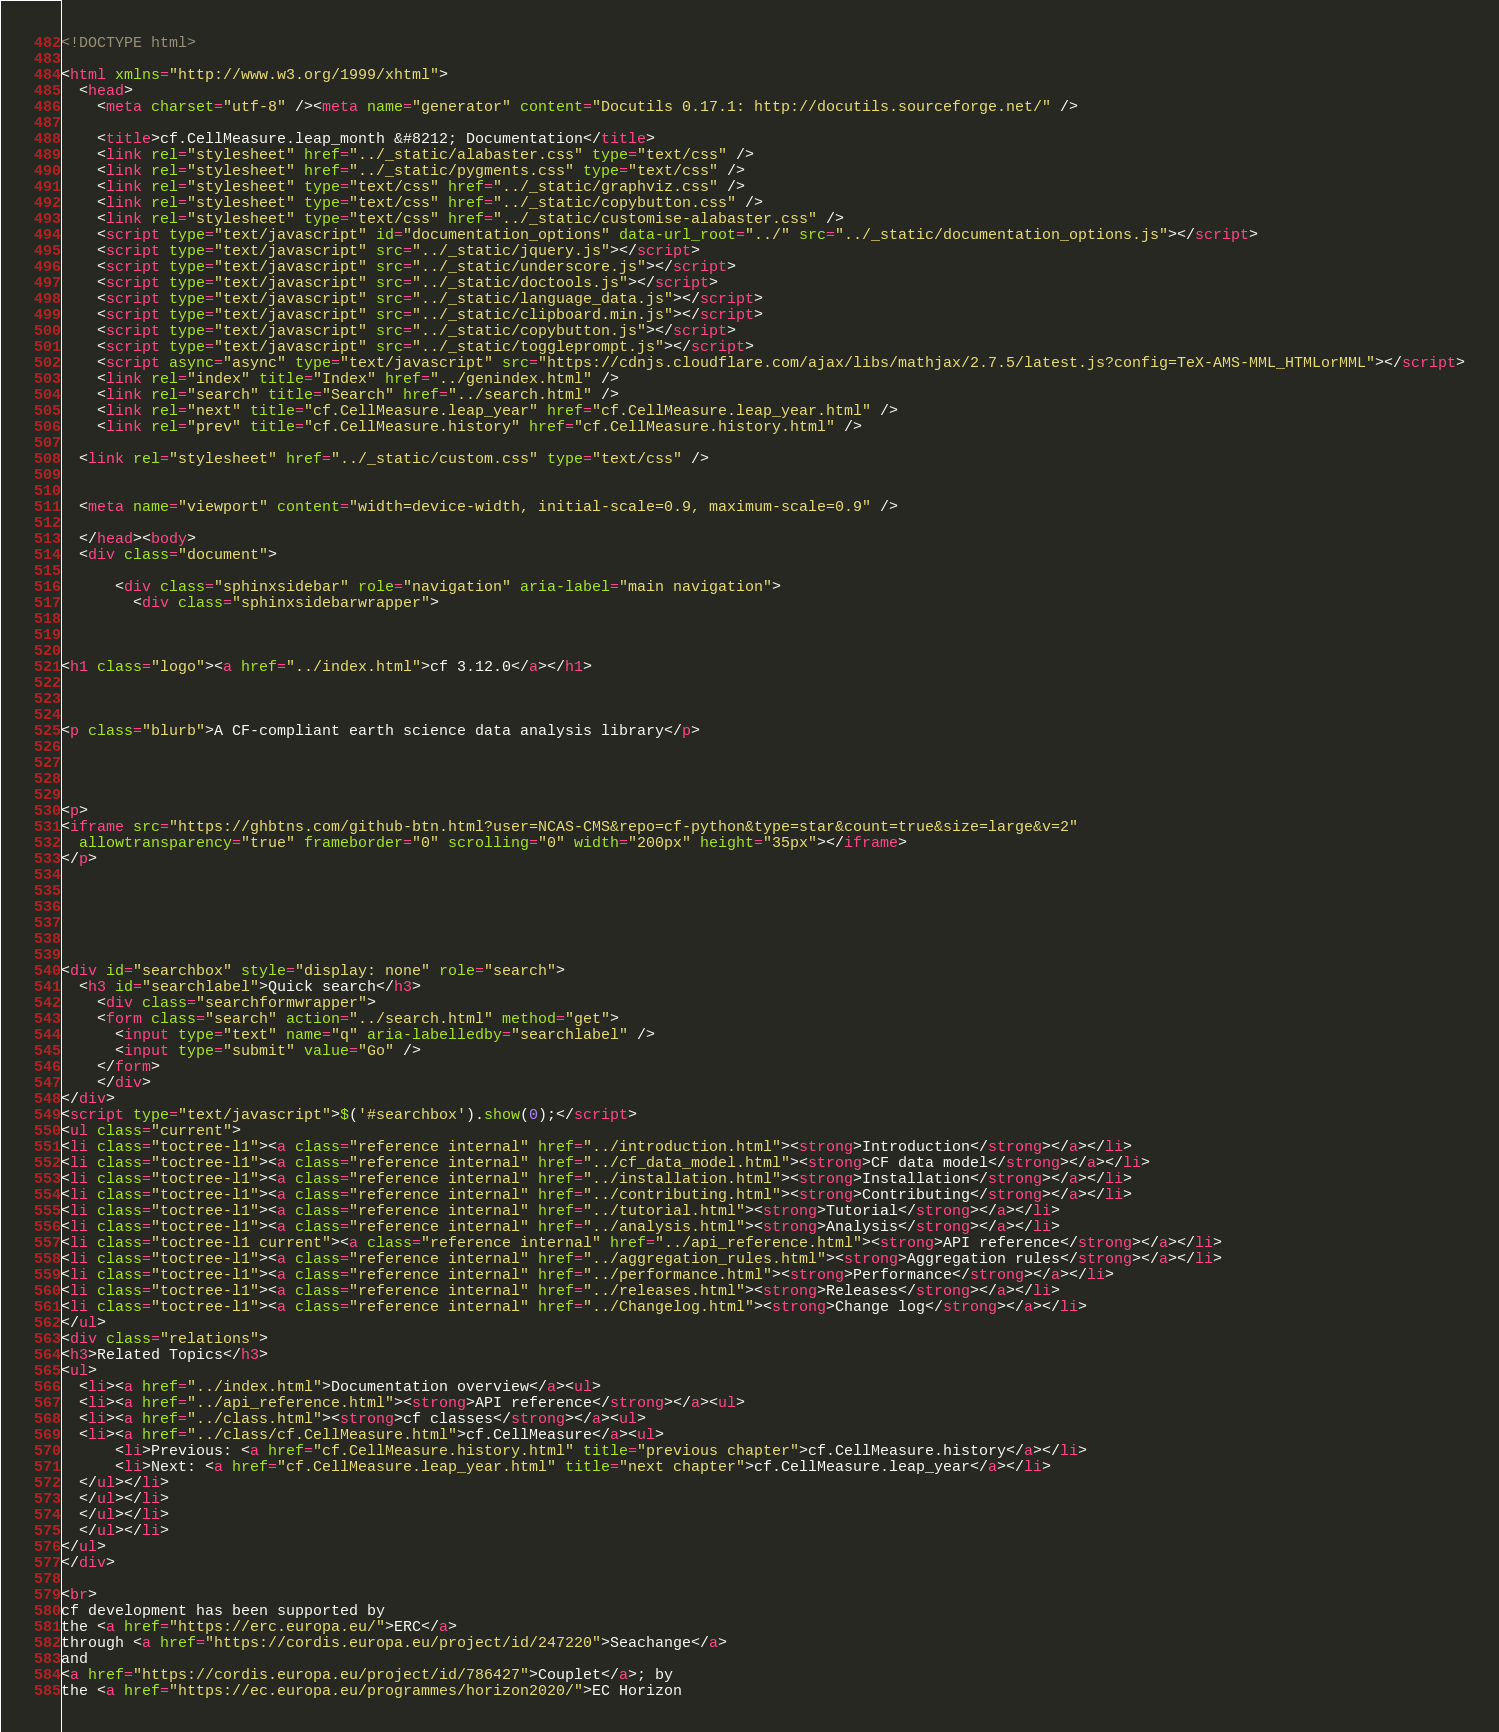<code> <loc_0><loc_0><loc_500><loc_500><_HTML_>
<!DOCTYPE html>

<html xmlns="http://www.w3.org/1999/xhtml">
  <head>
    <meta charset="utf-8" /><meta name="generator" content="Docutils 0.17.1: http://docutils.sourceforge.net/" />

    <title>cf.CellMeasure.leap_month &#8212; Documentation</title>
    <link rel="stylesheet" href="../_static/alabaster.css" type="text/css" />
    <link rel="stylesheet" href="../_static/pygments.css" type="text/css" />
    <link rel="stylesheet" type="text/css" href="../_static/graphviz.css" />
    <link rel="stylesheet" type="text/css" href="../_static/copybutton.css" />
    <link rel="stylesheet" type="text/css" href="../_static/customise-alabaster.css" />
    <script type="text/javascript" id="documentation_options" data-url_root="../" src="../_static/documentation_options.js"></script>
    <script type="text/javascript" src="../_static/jquery.js"></script>
    <script type="text/javascript" src="../_static/underscore.js"></script>
    <script type="text/javascript" src="../_static/doctools.js"></script>
    <script type="text/javascript" src="../_static/language_data.js"></script>
    <script type="text/javascript" src="../_static/clipboard.min.js"></script>
    <script type="text/javascript" src="../_static/copybutton.js"></script>
    <script type="text/javascript" src="../_static/toggleprompt.js"></script>
    <script async="async" type="text/javascript" src="https://cdnjs.cloudflare.com/ajax/libs/mathjax/2.7.5/latest.js?config=TeX-AMS-MML_HTMLorMML"></script>
    <link rel="index" title="Index" href="../genindex.html" />
    <link rel="search" title="Search" href="../search.html" />
    <link rel="next" title="cf.CellMeasure.leap_year" href="cf.CellMeasure.leap_year.html" />
    <link rel="prev" title="cf.CellMeasure.history" href="cf.CellMeasure.history.html" />
   
  <link rel="stylesheet" href="../_static/custom.css" type="text/css" />
  
  
  <meta name="viewport" content="width=device-width, initial-scale=0.9, maximum-scale=0.9" />

  </head><body>
  <div class="document">
    
      <div class="sphinxsidebar" role="navigation" aria-label="main navigation">
        <div class="sphinxsidebarwrapper">



<h1 class="logo"><a href="../index.html">cf 3.12.0</a></h1>



<p class="blurb">A CF-compliant earth science data analysis library</p>




<p>
<iframe src="https://ghbtns.com/github-btn.html?user=NCAS-CMS&repo=cf-python&type=star&count=true&size=large&v=2"
  allowtransparency="true" frameborder="0" scrolling="0" width="200px" height="35px"></iframe>
</p>






<div id="searchbox" style="display: none" role="search">
  <h3 id="searchlabel">Quick search</h3>
    <div class="searchformwrapper">
    <form class="search" action="../search.html" method="get">
      <input type="text" name="q" aria-labelledby="searchlabel" />
      <input type="submit" value="Go" />
    </form>
    </div>
</div>
<script type="text/javascript">$('#searchbox').show(0);</script>
<ul class="current">
<li class="toctree-l1"><a class="reference internal" href="../introduction.html"><strong>Introduction</strong></a></li>
<li class="toctree-l1"><a class="reference internal" href="../cf_data_model.html"><strong>CF data model</strong></a></li>
<li class="toctree-l1"><a class="reference internal" href="../installation.html"><strong>Installation</strong></a></li>
<li class="toctree-l1"><a class="reference internal" href="../contributing.html"><strong>Contributing</strong></a></li>
<li class="toctree-l1"><a class="reference internal" href="../tutorial.html"><strong>Tutorial</strong></a></li>
<li class="toctree-l1"><a class="reference internal" href="../analysis.html"><strong>Analysis</strong></a></li>
<li class="toctree-l1 current"><a class="reference internal" href="../api_reference.html"><strong>API reference</strong></a></li>
<li class="toctree-l1"><a class="reference internal" href="../aggregation_rules.html"><strong>Aggregation rules</strong></a></li>
<li class="toctree-l1"><a class="reference internal" href="../performance.html"><strong>Performance</strong></a></li>
<li class="toctree-l1"><a class="reference internal" href="../releases.html"><strong>Releases</strong></a></li>
<li class="toctree-l1"><a class="reference internal" href="../Changelog.html"><strong>Change log</strong></a></li>
</ul>
<div class="relations">
<h3>Related Topics</h3>
<ul>
  <li><a href="../index.html">Documentation overview</a><ul>
  <li><a href="../api_reference.html"><strong>API reference</strong></a><ul>
  <li><a href="../class.html"><strong>cf classes</strong></a><ul>
  <li><a href="../class/cf.CellMeasure.html">cf.CellMeasure</a><ul>
      <li>Previous: <a href="cf.CellMeasure.history.html" title="previous chapter">cf.CellMeasure.history</a></li>
      <li>Next: <a href="cf.CellMeasure.leap_year.html" title="next chapter">cf.CellMeasure.leap_year</a></li>
  </ul></li>
  </ul></li>
  </ul></li>
  </ul></li>
</ul>
</div>

<br>
cf development has been supported by
the <a href="https://erc.europa.eu/">ERC</a>
through <a href="https://cordis.europa.eu/project/id/247220">Seachange</a>
and
<a href="https://cordis.europa.eu/project/id/786427">Couplet</a>; by
the <a href="https://ec.europa.eu/programmes/horizon2020/">EC Horizon</code> 